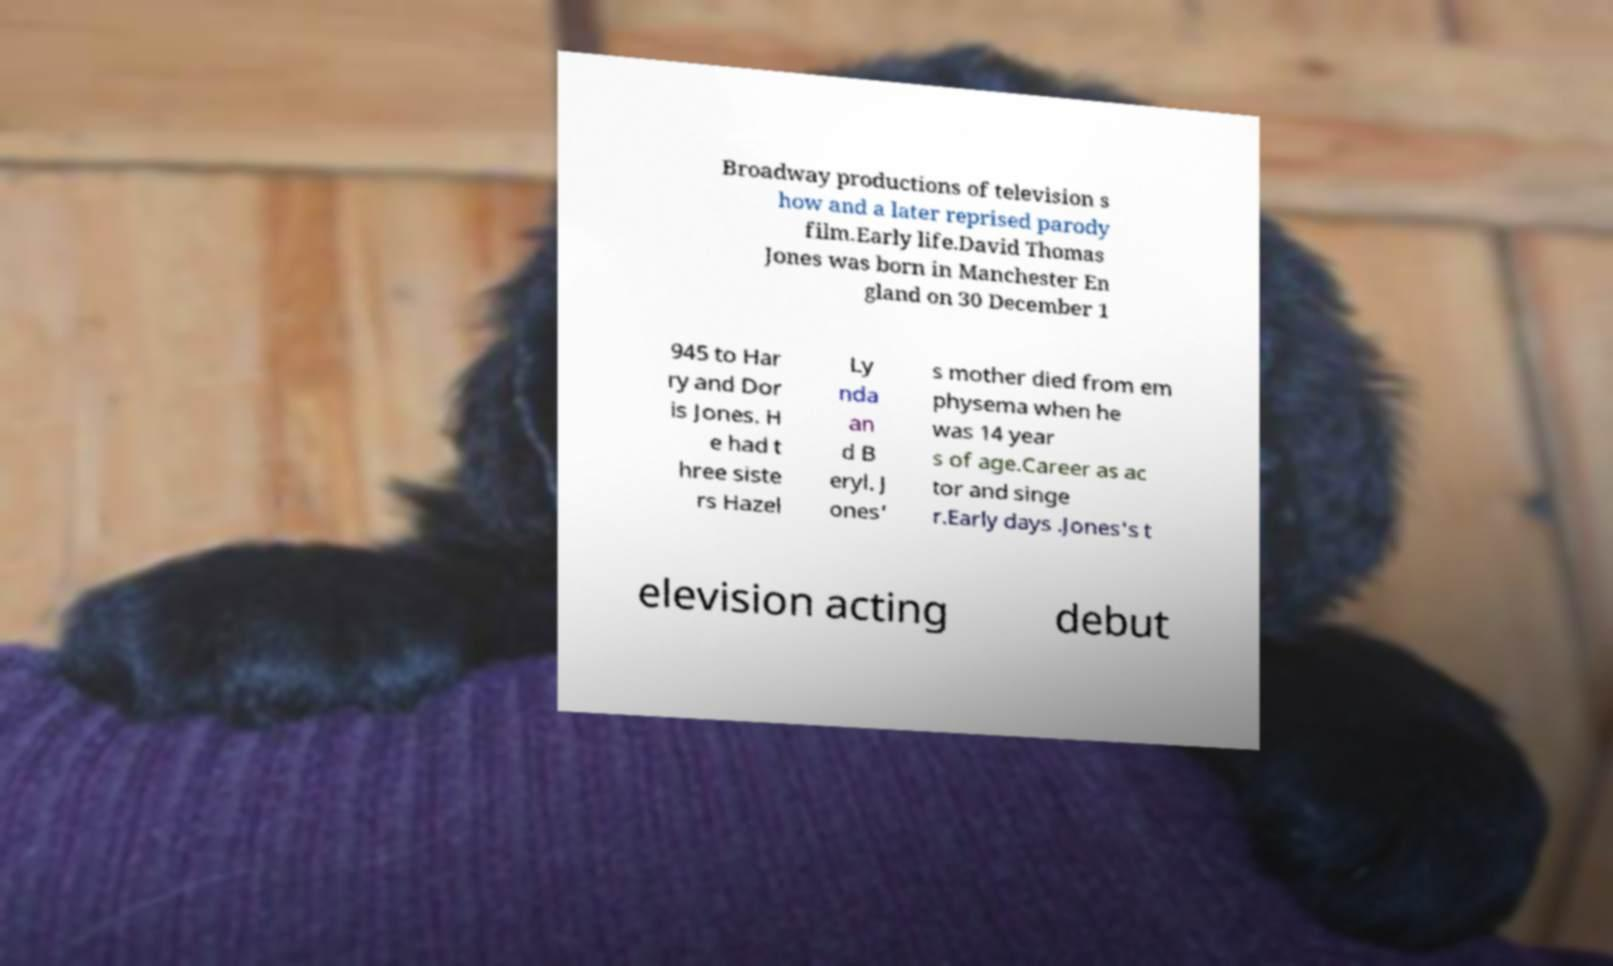Can you accurately transcribe the text from the provided image for me? Broadway productions of television s how and a later reprised parody film.Early life.David Thomas Jones was born in Manchester En gland on 30 December 1 945 to Har ry and Dor is Jones. H e had t hree siste rs Hazel Ly nda an d B eryl. J ones' s mother died from em physema when he was 14 year s of age.Career as ac tor and singe r.Early days .Jones's t elevision acting debut 